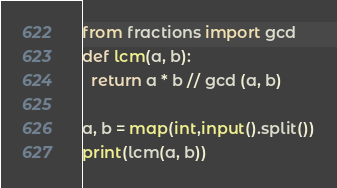<code> <loc_0><loc_0><loc_500><loc_500><_Python_>from fractions import gcd
def lcm(a, b):
  return a * b // gcd (a, b)

a, b = map(int,input().split())
print(lcm(a, b))
</code> 